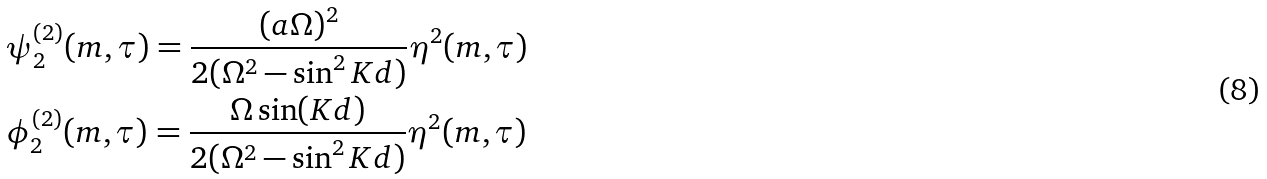Convert formula to latex. <formula><loc_0><loc_0><loc_500><loc_500>& \psi _ { 2 } ^ { ( 2 ) } ( m , \tau ) = \frac { ( a \Omega ) ^ { 2 } } { 2 ( \Omega ^ { 2 } - \sin ^ { 2 } K d ) } \eta ^ { 2 } ( m , \tau ) \\ & \phi _ { 2 } ^ { ( 2 ) } ( m , \tau ) = \frac { \Omega \sin ( K d ) } { 2 ( \Omega ^ { 2 } - \sin ^ { 2 } K d ) } \eta ^ { 2 } ( m , \tau )</formula> 